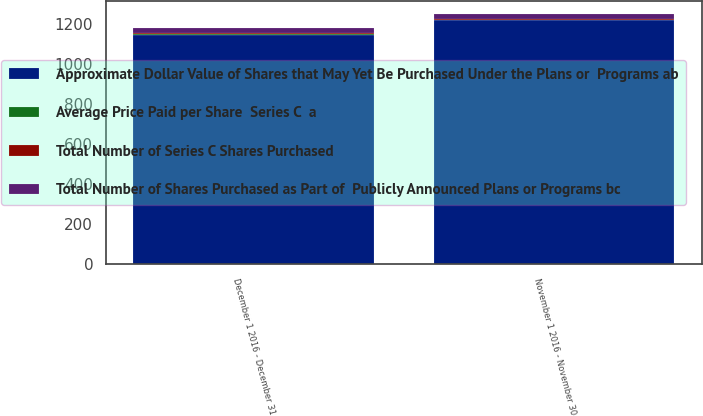Convert chart. <chart><loc_0><loc_0><loc_500><loc_500><stacked_bar_chart><ecel><fcel>November 1 2016 - November 30<fcel>December 1 2016 - December 31<nl><fcel>Average Price Paid per Share  Series C  a<fcel>2.8<fcel>2.8<nl><fcel>Total Number of Shares Purchased as Part of  Publicly Announced Plans or Programs bc<fcel>25.16<fcel>25.24<nl><fcel>Total Number of Series C Shares Purchased<fcel>2.8<fcel>2.8<nl><fcel>Approximate Dollar Value of Shares that May Yet Be Purchased Under the Plans or  Programs ab<fcel>1217<fcel>1145<nl></chart> 